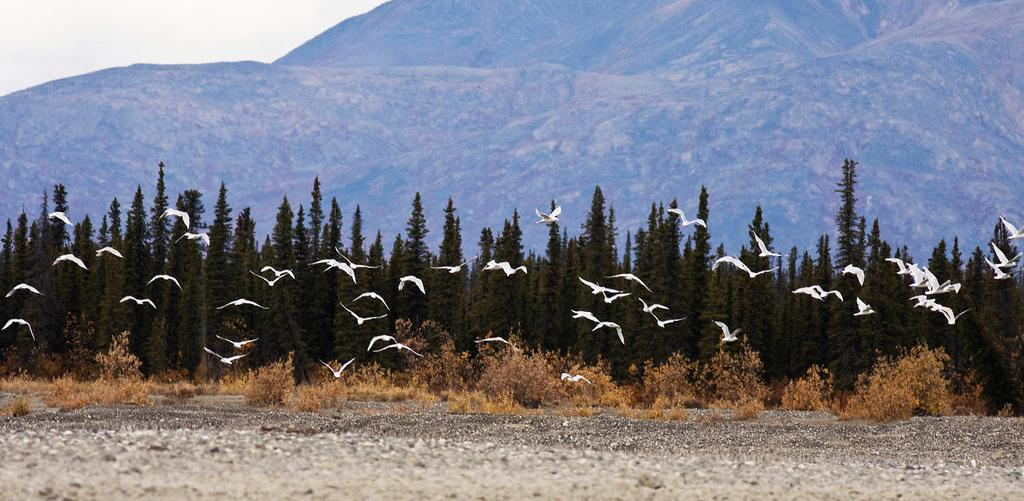What is happening in the image? There are birds flying in the image. What can be seen in the background of the image? There are trees, mountains, and the sky visible in the background of the image. What type of wool is being used to make the bath in the image? There is no bath or wool present in the image; it features birds flying in front of trees, mountains, and the sky. 